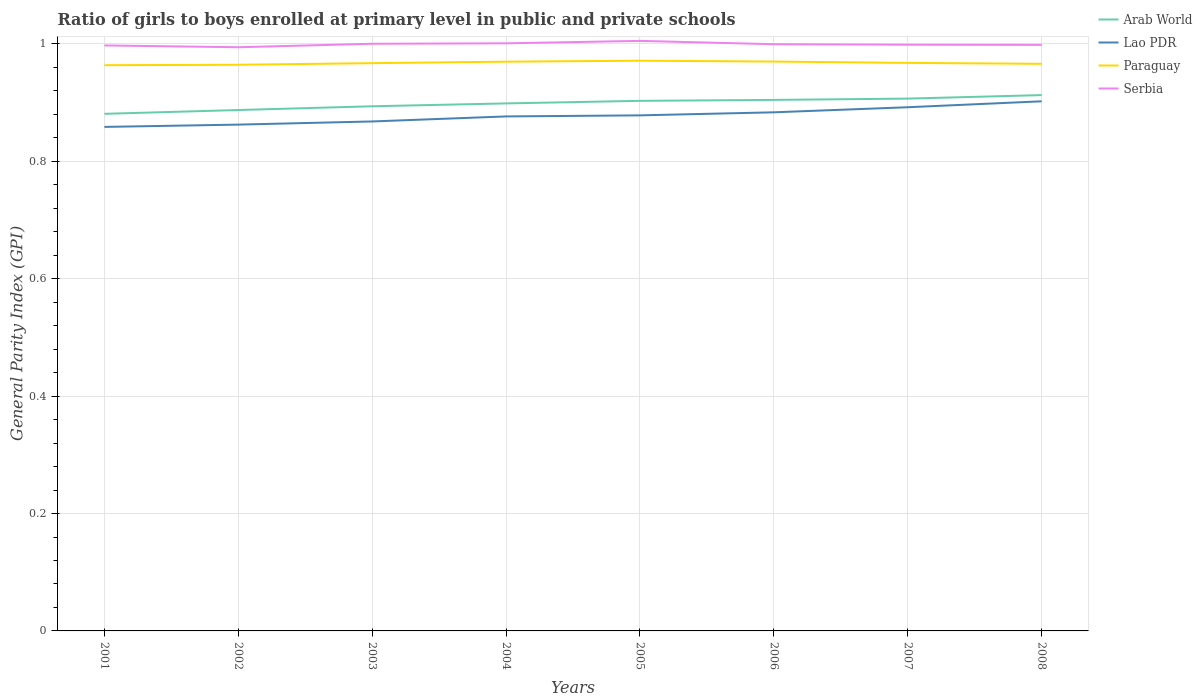How many different coloured lines are there?
Offer a terse response. 4. Does the line corresponding to Arab World intersect with the line corresponding to Serbia?
Give a very brief answer. No. Is the number of lines equal to the number of legend labels?
Offer a terse response. Yes. Across all years, what is the maximum general parity index in Lao PDR?
Ensure brevity in your answer.  0.86. What is the total general parity index in Serbia in the graph?
Make the answer very short. 0. What is the difference between the highest and the second highest general parity index in Paraguay?
Make the answer very short. 0.01. Are the values on the major ticks of Y-axis written in scientific E-notation?
Your response must be concise. No. Does the graph contain any zero values?
Your answer should be compact. No. What is the title of the graph?
Your answer should be compact. Ratio of girls to boys enrolled at primary level in public and private schools. What is the label or title of the Y-axis?
Your answer should be compact. General Parity Index (GPI). What is the General Parity Index (GPI) in Arab World in 2001?
Your answer should be very brief. 0.88. What is the General Parity Index (GPI) of Lao PDR in 2001?
Make the answer very short. 0.86. What is the General Parity Index (GPI) of Paraguay in 2001?
Provide a short and direct response. 0.96. What is the General Parity Index (GPI) of Serbia in 2001?
Provide a short and direct response. 1. What is the General Parity Index (GPI) of Arab World in 2002?
Make the answer very short. 0.89. What is the General Parity Index (GPI) in Lao PDR in 2002?
Your response must be concise. 0.86. What is the General Parity Index (GPI) in Paraguay in 2002?
Keep it short and to the point. 0.96. What is the General Parity Index (GPI) in Serbia in 2002?
Offer a terse response. 0.99. What is the General Parity Index (GPI) of Arab World in 2003?
Your response must be concise. 0.89. What is the General Parity Index (GPI) in Lao PDR in 2003?
Your answer should be compact. 0.87. What is the General Parity Index (GPI) of Paraguay in 2003?
Provide a succinct answer. 0.97. What is the General Parity Index (GPI) of Serbia in 2003?
Your answer should be very brief. 1. What is the General Parity Index (GPI) in Arab World in 2004?
Provide a short and direct response. 0.9. What is the General Parity Index (GPI) in Lao PDR in 2004?
Your answer should be compact. 0.88. What is the General Parity Index (GPI) in Paraguay in 2004?
Keep it short and to the point. 0.97. What is the General Parity Index (GPI) in Serbia in 2004?
Your answer should be compact. 1. What is the General Parity Index (GPI) in Arab World in 2005?
Provide a short and direct response. 0.9. What is the General Parity Index (GPI) in Lao PDR in 2005?
Offer a terse response. 0.88. What is the General Parity Index (GPI) of Paraguay in 2005?
Keep it short and to the point. 0.97. What is the General Parity Index (GPI) of Serbia in 2005?
Keep it short and to the point. 1.01. What is the General Parity Index (GPI) of Arab World in 2006?
Your answer should be very brief. 0.9. What is the General Parity Index (GPI) in Lao PDR in 2006?
Your answer should be very brief. 0.88. What is the General Parity Index (GPI) of Paraguay in 2006?
Offer a very short reply. 0.97. What is the General Parity Index (GPI) of Serbia in 2006?
Your response must be concise. 1. What is the General Parity Index (GPI) of Arab World in 2007?
Give a very brief answer. 0.91. What is the General Parity Index (GPI) in Lao PDR in 2007?
Your response must be concise. 0.89. What is the General Parity Index (GPI) of Paraguay in 2007?
Ensure brevity in your answer.  0.97. What is the General Parity Index (GPI) of Serbia in 2007?
Your response must be concise. 1. What is the General Parity Index (GPI) in Arab World in 2008?
Give a very brief answer. 0.91. What is the General Parity Index (GPI) in Lao PDR in 2008?
Offer a very short reply. 0.9. What is the General Parity Index (GPI) of Paraguay in 2008?
Provide a short and direct response. 0.97. What is the General Parity Index (GPI) in Serbia in 2008?
Ensure brevity in your answer.  1. Across all years, what is the maximum General Parity Index (GPI) of Arab World?
Offer a very short reply. 0.91. Across all years, what is the maximum General Parity Index (GPI) of Lao PDR?
Offer a terse response. 0.9. Across all years, what is the maximum General Parity Index (GPI) in Paraguay?
Offer a very short reply. 0.97. Across all years, what is the maximum General Parity Index (GPI) of Serbia?
Give a very brief answer. 1.01. Across all years, what is the minimum General Parity Index (GPI) in Arab World?
Make the answer very short. 0.88. Across all years, what is the minimum General Parity Index (GPI) of Lao PDR?
Make the answer very short. 0.86. Across all years, what is the minimum General Parity Index (GPI) in Paraguay?
Your answer should be compact. 0.96. Across all years, what is the minimum General Parity Index (GPI) in Serbia?
Offer a very short reply. 0.99. What is the total General Parity Index (GPI) in Arab World in the graph?
Keep it short and to the point. 7.19. What is the total General Parity Index (GPI) in Lao PDR in the graph?
Your answer should be very brief. 7.02. What is the total General Parity Index (GPI) in Paraguay in the graph?
Ensure brevity in your answer.  7.74. What is the total General Parity Index (GPI) of Serbia in the graph?
Provide a short and direct response. 8. What is the difference between the General Parity Index (GPI) in Arab World in 2001 and that in 2002?
Your response must be concise. -0.01. What is the difference between the General Parity Index (GPI) of Lao PDR in 2001 and that in 2002?
Provide a short and direct response. -0. What is the difference between the General Parity Index (GPI) of Paraguay in 2001 and that in 2002?
Your answer should be compact. -0. What is the difference between the General Parity Index (GPI) in Serbia in 2001 and that in 2002?
Your response must be concise. 0. What is the difference between the General Parity Index (GPI) in Arab World in 2001 and that in 2003?
Offer a very short reply. -0.01. What is the difference between the General Parity Index (GPI) in Lao PDR in 2001 and that in 2003?
Make the answer very short. -0.01. What is the difference between the General Parity Index (GPI) in Paraguay in 2001 and that in 2003?
Give a very brief answer. -0. What is the difference between the General Parity Index (GPI) in Serbia in 2001 and that in 2003?
Your response must be concise. -0. What is the difference between the General Parity Index (GPI) in Arab World in 2001 and that in 2004?
Your response must be concise. -0.02. What is the difference between the General Parity Index (GPI) of Lao PDR in 2001 and that in 2004?
Ensure brevity in your answer.  -0.02. What is the difference between the General Parity Index (GPI) in Paraguay in 2001 and that in 2004?
Keep it short and to the point. -0.01. What is the difference between the General Parity Index (GPI) of Serbia in 2001 and that in 2004?
Your answer should be compact. -0. What is the difference between the General Parity Index (GPI) in Arab World in 2001 and that in 2005?
Offer a very short reply. -0.02. What is the difference between the General Parity Index (GPI) in Lao PDR in 2001 and that in 2005?
Make the answer very short. -0.02. What is the difference between the General Parity Index (GPI) in Paraguay in 2001 and that in 2005?
Your answer should be compact. -0.01. What is the difference between the General Parity Index (GPI) of Serbia in 2001 and that in 2005?
Make the answer very short. -0.01. What is the difference between the General Parity Index (GPI) in Arab World in 2001 and that in 2006?
Make the answer very short. -0.02. What is the difference between the General Parity Index (GPI) in Lao PDR in 2001 and that in 2006?
Your answer should be compact. -0.02. What is the difference between the General Parity Index (GPI) in Paraguay in 2001 and that in 2006?
Ensure brevity in your answer.  -0.01. What is the difference between the General Parity Index (GPI) in Serbia in 2001 and that in 2006?
Provide a short and direct response. -0. What is the difference between the General Parity Index (GPI) in Arab World in 2001 and that in 2007?
Offer a terse response. -0.03. What is the difference between the General Parity Index (GPI) of Lao PDR in 2001 and that in 2007?
Provide a short and direct response. -0.03. What is the difference between the General Parity Index (GPI) of Paraguay in 2001 and that in 2007?
Provide a short and direct response. -0. What is the difference between the General Parity Index (GPI) of Serbia in 2001 and that in 2007?
Your response must be concise. -0. What is the difference between the General Parity Index (GPI) in Arab World in 2001 and that in 2008?
Your answer should be compact. -0.03. What is the difference between the General Parity Index (GPI) in Lao PDR in 2001 and that in 2008?
Provide a succinct answer. -0.04. What is the difference between the General Parity Index (GPI) in Paraguay in 2001 and that in 2008?
Your answer should be very brief. -0. What is the difference between the General Parity Index (GPI) of Serbia in 2001 and that in 2008?
Offer a terse response. -0. What is the difference between the General Parity Index (GPI) of Arab World in 2002 and that in 2003?
Keep it short and to the point. -0.01. What is the difference between the General Parity Index (GPI) of Lao PDR in 2002 and that in 2003?
Your answer should be compact. -0.01. What is the difference between the General Parity Index (GPI) of Paraguay in 2002 and that in 2003?
Your answer should be very brief. -0. What is the difference between the General Parity Index (GPI) in Serbia in 2002 and that in 2003?
Give a very brief answer. -0.01. What is the difference between the General Parity Index (GPI) in Arab World in 2002 and that in 2004?
Offer a terse response. -0.01. What is the difference between the General Parity Index (GPI) in Lao PDR in 2002 and that in 2004?
Ensure brevity in your answer.  -0.01. What is the difference between the General Parity Index (GPI) in Paraguay in 2002 and that in 2004?
Make the answer very short. -0.01. What is the difference between the General Parity Index (GPI) in Serbia in 2002 and that in 2004?
Make the answer very short. -0.01. What is the difference between the General Parity Index (GPI) of Arab World in 2002 and that in 2005?
Your answer should be very brief. -0.02. What is the difference between the General Parity Index (GPI) of Lao PDR in 2002 and that in 2005?
Make the answer very short. -0.02. What is the difference between the General Parity Index (GPI) of Paraguay in 2002 and that in 2005?
Provide a succinct answer. -0.01. What is the difference between the General Parity Index (GPI) in Serbia in 2002 and that in 2005?
Keep it short and to the point. -0.01. What is the difference between the General Parity Index (GPI) of Arab World in 2002 and that in 2006?
Make the answer very short. -0.02. What is the difference between the General Parity Index (GPI) of Lao PDR in 2002 and that in 2006?
Provide a short and direct response. -0.02. What is the difference between the General Parity Index (GPI) of Paraguay in 2002 and that in 2006?
Make the answer very short. -0.01. What is the difference between the General Parity Index (GPI) of Serbia in 2002 and that in 2006?
Your answer should be very brief. -0.01. What is the difference between the General Parity Index (GPI) in Arab World in 2002 and that in 2007?
Give a very brief answer. -0.02. What is the difference between the General Parity Index (GPI) in Lao PDR in 2002 and that in 2007?
Your response must be concise. -0.03. What is the difference between the General Parity Index (GPI) in Paraguay in 2002 and that in 2007?
Offer a very short reply. -0. What is the difference between the General Parity Index (GPI) in Serbia in 2002 and that in 2007?
Offer a very short reply. -0. What is the difference between the General Parity Index (GPI) in Arab World in 2002 and that in 2008?
Provide a short and direct response. -0.03. What is the difference between the General Parity Index (GPI) of Lao PDR in 2002 and that in 2008?
Your answer should be compact. -0.04. What is the difference between the General Parity Index (GPI) of Paraguay in 2002 and that in 2008?
Keep it short and to the point. -0. What is the difference between the General Parity Index (GPI) of Serbia in 2002 and that in 2008?
Make the answer very short. -0. What is the difference between the General Parity Index (GPI) of Arab World in 2003 and that in 2004?
Give a very brief answer. -0. What is the difference between the General Parity Index (GPI) of Lao PDR in 2003 and that in 2004?
Provide a succinct answer. -0.01. What is the difference between the General Parity Index (GPI) of Paraguay in 2003 and that in 2004?
Make the answer very short. -0. What is the difference between the General Parity Index (GPI) in Serbia in 2003 and that in 2004?
Ensure brevity in your answer.  -0. What is the difference between the General Parity Index (GPI) in Arab World in 2003 and that in 2005?
Ensure brevity in your answer.  -0.01. What is the difference between the General Parity Index (GPI) of Lao PDR in 2003 and that in 2005?
Your answer should be very brief. -0.01. What is the difference between the General Parity Index (GPI) in Paraguay in 2003 and that in 2005?
Provide a short and direct response. -0. What is the difference between the General Parity Index (GPI) of Serbia in 2003 and that in 2005?
Make the answer very short. -0. What is the difference between the General Parity Index (GPI) in Arab World in 2003 and that in 2006?
Offer a very short reply. -0.01. What is the difference between the General Parity Index (GPI) of Lao PDR in 2003 and that in 2006?
Make the answer very short. -0.02. What is the difference between the General Parity Index (GPI) of Paraguay in 2003 and that in 2006?
Make the answer very short. -0. What is the difference between the General Parity Index (GPI) in Serbia in 2003 and that in 2006?
Keep it short and to the point. 0. What is the difference between the General Parity Index (GPI) in Arab World in 2003 and that in 2007?
Your response must be concise. -0.01. What is the difference between the General Parity Index (GPI) in Lao PDR in 2003 and that in 2007?
Give a very brief answer. -0.02. What is the difference between the General Parity Index (GPI) in Paraguay in 2003 and that in 2007?
Your answer should be compact. -0. What is the difference between the General Parity Index (GPI) of Serbia in 2003 and that in 2007?
Give a very brief answer. 0. What is the difference between the General Parity Index (GPI) of Arab World in 2003 and that in 2008?
Provide a succinct answer. -0.02. What is the difference between the General Parity Index (GPI) of Lao PDR in 2003 and that in 2008?
Your answer should be compact. -0.03. What is the difference between the General Parity Index (GPI) of Paraguay in 2003 and that in 2008?
Ensure brevity in your answer.  0. What is the difference between the General Parity Index (GPI) in Serbia in 2003 and that in 2008?
Your answer should be compact. 0. What is the difference between the General Parity Index (GPI) of Arab World in 2004 and that in 2005?
Give a very brief answer. -0. What is the difference between the General Parity Index (GPI) in Lao PDR in 2004 and that in 2005?
Offer a terse response. -0. What is the difference between the General Parity Index (GPI) of Paraguay in 2004 and that in 2005?
Give a very brief answer. -0. What is the difference between the General Parity Index (GPI) of Serbia in 2004 and that in 2005?
Ensure brevity in your answer.  -0. What is the difference between the General Parity Index (GPI) in Arab World in 2004 and that in 2006?
Offer a terse response. -0.01. What is the difference between the General Parity Index (GPI) in Lao PDR in 2004 and that in 2006?
Your response must be concise. -0.01. What is the difference between the General Parity Index (GPI) of Paraguay in 2004 and that in 2006?
Give a very brief answer. -0. What is the difference between the General Parity Index (GPI) in Serbia in 2004 and that in 2006?
Keep it short and to the point. 0. What is the difference between the General Parity Index (GPI) of Arab World in 2004 and that in 2007?
Make the answer very short. -0.01. What is the difference between the General Parity Index (GPI) of Lao PDR in 2004 and that in 2007?
Keep it short and to the point. -0.02. What is the difference between the General Parity Index (GPI) of Paraguay in 2004 and that in 2007?
Ensure brevity in your answer.  0. What is the difference between the General Parity Index (GPI) of Serbia in 2004 and that in 2007?
Keep it short and to the point. 0. What is the difference between the General Parity Index (GPI) of Arab World in 2004 and that in 2008?
Your response must be concise. -0.01. What is the difference between the General Parity Index (GPI) of Lao PDR in 2004 and that in 2008?
Your answer should be compact. -0.03. What is the difference between the General Parity Index (GPI) of Paraguay in 2004 and that in 2008?
Ensure brevity in your answer.  0. What is the difference between the General Parity Index (GPI) of Serbia in 2004 and that in 2008?
Make the answer very short. 0. What is the difference between the General Parity Index (GPI) in Arab World in 2005 and that in 2006?
Give a very brief answer. -0. What is the difference between the General Parity Index (GPI) of Lao PDR in 2005 and that in 2006?
Ensure brevity in your answer.  -0.01. What is the difference between the General Parity Index (GPI) in Paraguay in 2005 and that in 2006?
Ensure brevity in your answer.  0. What is the difference between the General Parity Index (GPI) in Serbia in 2005 and that in 2006?
Your answer should be compact. 0.01. What is the difference between the General Parity Index (GPI) in Arab World in 2005 and that in 2007?
Your answer should be compact. -0. What is the difference between the General Parity Index (GPI) in Lao PDR in 2005 and that in 2007?
Provide a succinct answer. -0.01. What is the difference between the General Parity Index (GPI) in Paraguay in 2005 and that in 2007?
Your answer should be very brief. 0. What is the difference between the General Parity Index (GPI) in Serbia in 2005 and that in 2007?
Your answer should be compact. 0.01. What is the difference between the General Parity Index (GPI) of Arab World in 2005 and that in 2008?
Keep it short and to the point. -0.01. What is the difference between the General Parity Index (GPI) of Lao PDR in 2005 and that in 2008?
Offer a terse response. -0.02. What is the difference between the General Parity Index (GPI) of Paraguay in 2005 and that in 2008?
Your answer should be compact. 0.01. What is the difference between the General Parity Index (GPI) of Serbia in 2005 and that in 2008?
Your answer should be very brief. 0.01. What is the difference between the General Parity Index (GPI) in Arab World in 2006 and that in 2007?
Give a very brief answer. -0. What is the difference between the General Parity Index (GPI) of Lao PDR in 2006 and that in 2007?
Your answer should be very brief. -0.01. What is the difference between the General Parity Index (GPI) in Paraguay in 2006 and that in 2007?
Your response must be concise. 0. What is the difference between the General Parity Index (GPI) in Serbia in 2006 and that in 2007?
Your response must be concise. 0. What is the difference between the General Parity Index (GPI) in Arab World in 2006 and that in 2008?
Give a very brief answer. -0.01. What is the difference between the General Parity Index (GPI) of Lao PDR in 2006 and that in 2008?
Your response must be concise. -0.02. What is the difference between the General Parity Index (GPI) of Paraguay in 2006 and that in 2008?
Your answer should be compact. 0. What is the difference between the General Parity Index (GPI) of Serbia in 2006 and that in 2008?
Keep it short and to the point. 0. What is the difference between the General Parity Index (GPI) in Arab World in 2007 and that in 2008?
Provide a short and direct response. -0.01. What is the difference between the General Parity Index (GPI) in Lao PDR in 2007 and that in 2008?
Make the answer very short. -0.01. What is the difference between the General Parity Index (GPI) of Paraguay in 2007 and that in 2008?
Provide a succinct answer. 0. What is the difference between the General Parity Index (GPI) in Serbia in 2007 and that in 2008?
Give a very brief answer. 0. What is the difference between the General Parity Index (GPI) of Arab World in 2001 and the General Parity Index (GPI) of Lao PDR in 2002?
Your answer should be very brief. 0.02. What is the difference between the General Parity Index (GPI) of Arab World in 2001 and the General Parity Index (GPI) of Paraguay in 2002?
Give a very brief answer. -0.08. What is the difference between the General Parity Index (GPI) of Arab World in 2001 and the General Parity Index (GPI) of Serbia in 2002?
Give a very brief answer. -0.11. What is the difference between the General Parity Index (GPI) in Lao PDR in 2001 and the General Parity Index (GPI) in Paraguay in 2002?
Your answer should be very brief. -0.11. What is the difference between the General Parity Index (GPI) in Lao PDR in 2001 and the General Parity Index (GPI) in Serbia in 2002?
Give a very brief answer. -0.14. What is the difference between the General Parity Index (GPI) in Paraguay in 2001 and the General Parity Index (GPI) in Serbia in 2002?
Offer a terse response. -0.03. What is the difference between the General Parity Index (GPI) of Arab World in 2001 and the General Parity Index (GPI) of Lao PDR in 2003?
Give a very brief answer. 0.01. What is the difference between the General Parity Index (GPI) in Arab World in 2001 and the General Parity Index (GPI) in Paraguay in 2003?
Keep it short and to the point. -0.09. What is the difference between the General Parity Index (GPI) in Arab World in 2001 and the General Parity Index (GPI) in Serbia in 2003?
Give a very brief answer. -0.12. What is the difference between the General Parity Index (GPI) of Lao PDR in 2001 and the General Parity Index (GPI) of Paraguay in 2003?
Your answer should be compact. -0.11. What is the difference between the General Parity Index (GPI) of Lao PDR in 2001 and the General Parity Index (GPI) of Serbia in 2003?
Keep it short and to the point. -0.14. What is the difference between the General Parity Index (GPI) of Paraguay in 2001 and the General Parity Index (GPI) of Serbia in 2003?
Your answer should be very brief. -0.04. What is the difference between the General Parity Index (GPI) of Arab World in 2001 and the General Parity Index (GPI) of Lao PDR in 2004?
Provide a succinct answer. 0. What is the difference between the General Parity Index (GPI) in Arab World in 2001 and the General Parity Index (GPI) in Paraguay in 2004?
Provide a succinct answer. -0.09. What is the difference between the General Parity Index (GPI) of Arab World in 2001 and the General Parity Index (GPI) of Serbia in 2004?
Your response must be concise. -0.12. What is the difference between the General Parity Index (GPI) of Lao PDR in 2001 and the General Parity Index (GPI) of Paraguay in 2004?
Provide a succinct answer. -0.11. What is the difference between the General Parity Index (GPI) of Lao PDR in 2001 and the General Parity Index (GPI) of Serbia in 2004?
Ensure brevity in your answer.  -0.14. What is the difference between the General Parity Index (GPI) in Paraguay in 2001 and the General Parity Index (GPI) in Serbia in 2004?
Offer a terse response. -0.04. What is the difference between the General Parity Index (GPI) in Arab World in 2001 and the General Parity Index (GPI) in Lao PDR in 2005?
Ensure brevity in your answer.  0. What is the difference between the General Parity Index (GPI) in Arab World in 2001 and the General Parity Index (GPI) in Paraguay in 2005?
Your answer should be very brief. -0.09. What is the difference between the General Parity Index (GPI) of Arab World in 2001 and the General Parity Index (GPI) of Serbia in 2005?
Offer a terse response. -0.12. What is the difference between the General Parity Index (GPI) of Lao PDR in 2001 and the General Parity Index (GPI) of Paraguay in 2005?
Make the answer very short. -0.11. What is the difference between the General Parity Index (GPI) in Lao PDR in 2001 and the General Parity Index (GPI) in Serbia in 2005?
Provide a short and direct response. -0.15. What is the difference between the General Parity Index (GPI) of Paraguay in 2001 and the General Parity Index (GPI) of Serbia in 2005?
Your answer should be compact. -0.04. What is the difference between the General Parity Index (GPI) of Arab World in 2001 and the General Parity Index (GPI) of Lao PDR in 2006?
Provide a succinct answer. -0. What is the difference between the General Parity Index (GPI) in Arab World in 2001 and the General Parity Index (GPI) in Paraguay in 2006?
Provide a succinct answer. -0.09. What is the difference between the General Parity Index (GPI) of Arab World in 2001 and the General Parity Index (GPI) of Serbia in 2006?
Provide a succinct answer. -0.12. What is the difference between the General Parity Index (GPI) in Lao PDR in 2001 and the General Parity Index (GPI) in Paraguay in 2006?
Your response must be concise. -0.11. What is the difference between the General Parity Index (GPI) in Lao PDR in 2001 and the General Parity Index (GPI) in Serbia in 2006?
Give a very brief answer. -0.14. What is the difference between the General Parity Index (GPI) of Paraguay in 2001 and the General Parity Index (GPI) of Serbia in 2006?
Keep it short and to the point. -0.04. What is the difference between the General Parity Index (GPI) of Arab World in 2001 and the General Parity Index (GPI) of Lao PDR in 2007?
Give a very brief answer. -0.01. What is the difference between the General Parity Index (GPI) in Arab World in 2001 and the General Parity Index (GPI) in Paraguay in 2007?
Offer a terse response. -0.09. What is the difference between the General Parity Index (GPI) in Arab World in 2001 and the General Parity Index (GPI) in Serbia in 2007?
Offer a very short reply. -0.12. What is the difference between the General Parity Index (GPI) in Lao PDR in 2001 and the General Parity Index (GPI) in Paraguay in 2007?
Offer a very short reply. -0.11. What is the difference between the General Parity Index (GPI) of Lao PDR in 2001 and the General Parity Index (GPI) of Serbia in 2007?
Provide a succinct answer. -0.14. What is the difference between the General Parity Index (GPI) in Paraguay in 2001 and the General Parity Index (GPI) in Serbia in 2007?
Give a very brief answer. -0.03. What is the difference between the General Parity Index (GPI) in Arab World in 2001 and the General Parity Index (GPI) in Lao PDR in 2008?
Provide a short and direct response. -0.02. What is the difference between the General Parity Index (GPI) of Arab World in 2001 and the General Parity Index (GPI) of Paraguay in 2008?
Provide a succinct answer. -0.09. What is the difference between the General Parity Index (GPI) in Arab World in 2001 and the General Parity Index (GPI) in Serbia in 2008?
Offer a terse response. -0.12. What is the difference between the General Parity Index (GPI) in Lao PDR in 2001 and the General Parity Index (GPI) in Paraguay in 2008?
Make the answer very short. -0.11. What is the difference between the General Parity Index (GPI) in Lao PDR in 2001 and the General Parity Index (GPI) in Serbia in 2008?
Ensure brevity in your answer.  -0.14. What is the difference between the General Parity Index (GPI) in Paraguay in 2001 and the General Parity Index (GPI) in Serbia in 2008?
Offer a terse response. -0.03. What is the difference between the General Parity Index (GPI) of Arab World in 2002 and the General Parity Index (GPI) of Lao PDR in 2003?
Make the answer very short. 0.02. What is the difference between the General Parity Index (GPI) in Arab World in 2002 and the General Parity Index (GPI) in Paraguay in 2003?
Ensure brevity in your answer.  -0.08. What is the difference between the General Parity Index (GPI) of Arab World in 2002 and the General Parity Index (GPI) of Serbia in 2003?
Your answer should be very brief. -0.11. What is the difference between the General Parity Index (GPI) of Lao PDR in 2002 and the General Parity Index (GPI) of Paraguay in 2003?
Give a very brief answer. -0.1. What is the difference between the General Parity Index (GPI) of Lao PDR in 2002 and the General Parity Index (GPI) of Serbia in 2003?
Make the answer very short. -0.14. What is the difference between the General Parity Index (GPI) of Paraguay in 2002 and the General Parity Index (GPI) of Serbia in 2003?
Your answer should be compact. -0.04. What is the difference between the General Parity Index (GPI) in Arab World in 2002 and the General Parity Index (GPI) in Lao PDR in 2004?
Offer a very short reply. 0.01. What is the difference between the General Parity Index (GPI) in Arab World in 2002 and the General Parity Index (GPI) in Paraguay in 2004?
Provide a succinct answer. -0.08. What is the difference between the General Parity Index (GPI) in Arab World in 2002 and the General Parity Index (GPI) in Serbia in 2004?
Provide a short and direct response. -0.11. What is the difference between the General Parity Index (GPI) of Lao PDR in 2002 and the General Parity Index (GPI) of Paraguay in 2004?
Provide a short and direct response. -0.11. What is the difference between the General Parity Index (GPI) of Lao PDR in 2002 and the General Parity Index (GPI) of Serbia in 2004?
Keep it short and to the point. -0.14. What is the difference between the General Parity Index (GPI) in Paraguay in 2002 and the General Parity Index (GPI) in Serbia in 2004?
Keep it short and to the point. -0.04. What is the difference between the General Parity Index (GPI) in Arab World in 2002 and the General Parity Index (GPI) in Lao PDR in 2005?
Give a very brief answer. 0.01. What is the difference between the General Parity Index (GPI) of Arab World in 2002 and the General Parity Index (GPI) of Paraguay in 2005?
Provide a succinct answer. -0.08. What is the difference between the General Parity Index (GPI) in Arab World in 2002 and the General Parity Index (GPI) in Serbia in 2005?
Provide a succinct answer. -0.12. What is the difference between the General Parity Index (GPI) of Lao PDR in 2002 and the General Parity Index (GPI) of Paraguay in 2005?
Provide a succinct answer. -0.11. What is the difference between the General Parity Index (GPI) of Lao PDR in 2002 and the General Parity Index (GPI) of Serbia in 2005?
Ensure brevity in your answer.  -0.14. What is the difference between the General Parity Index (GPI) of Paraguay in 2002 and the General Parity Index (GPI) of Serbia in 2005?
Your answer should be compact. -0.04. What is the difference between the General Parity Index (GPI) of Arab World in 2002 and the General Parity Index (GPI) of Lao PDR in 2006?
Ensure brevity in your answer.  0. What is the difference between the General Parity Index (GPI) of Arab World in 2002 and the General Parity Index (GPI) of Paraguay in 2006?
Keep it short and to the point. -0.08. What is the difference between the General Parity Index (GPI) in Arab World in 2002 and the General Parity Index (GPI) in Serbia in 2006?
Ensure brevity in your answer.  -0.11. What is the difference between the General Parity Index (GPI) in Lao PDR in 2002 and the General Parity Index (GPI) in Paraguay in 2006?
Your answer should be very brief. -0.11. What is the difference between the General Parity Index (GPI) of Lao PDR in 2002 and the General Parity Index (GPI) of Serbia in 2006?
Offer a terse response. -0.14. What is the difference between the General Parity Index (GPI) in Paraguay in 2002 and the General Parity Index (GPI) in Serbia in 2006?
Offer a very short reply. -0.04. What is the difference between the General Parity Index (GPI) in Arab World in 2002 and the General Parity Index (GPI) in Lao PDR in 2007?
Your answer should be compact. -0. What is the difference between the General Parity Index (GPI) of Arab World in 2002 and the General Parity Index (GPI) of Paraguay in 2007?
Provide a succinct answer. -0.08. What is the difference between the General Parity Index (GPI) of Arab World in 2002 and the General Parity Index (GPI) of Serbia in 2007?
Offer a very short reply. -0.11. What is the difference between the General Parity Index (GPI) of Lao PDR in 2002 and the General Parity Index (GPI) of Paraguay in 2007?
Offer a very short reply. -0.11. What is the difference between the General Parity Index (GPI) in Lao PDR in 2002 and the General Parity Index (GPI) in Serbia in 2007?
Make the answer very short. -0.14. What is the difference between the General Parity Index (GPI) of Paraguay in 2002 and the General Parity Index (GPI) of Serbia in 2007?
Provide a short and direct response. -0.03. What is the difference between the General Parity Index (GPI) of Arab World in 2002 and the General Parity Index (GPI) of Lao PDR in 2008?
Your answer should be compact. -0.01. What is the difference between the General Parity Index (GPI) in Arab World in 2002 and the General Parity Index (GPI) in Paraguay in 2008?
Provide a succinct answer. -0.08. What is the difference between the General Parity Index (GPI) of Arab World in 2002 and the General Parity Index (GPI) of Serbia in 2008?
Offer a very short reply. -0.11. What is the difference between the General Parity Index (GPI) in Lao PDR in 2002 and the General Parity Index (GPI) in Paraguay in 2008?
Your response must be concise. -0.1. What is the difference between the General Parity Index (GPI) of Lao PDR in 2002 and the General Parity Index (GPI) of Serbia in 2008?
Offer a terse response. -0.14. What is the difference between the General Parity Index (GPI) in Paraguay in 2002 and the General Parity Index (GPI) in Serbia in 2008?
Give a very brief answer. -0.03. What is the difference between the General Parity Index (GPI) of Arab World in 2003 and the General Parity Index (GPI) of Lao PDR in 2004?
Your answer should be compact. 0.02. What is the difference between the General Parity Index (GPI) of Arab World in 2003 and the General Parity Index (GPI) of Paraguay in 2004?
Keep it short and to the point. -0.08. What is the difference between the General Parity Index (GPI) in Arab World in 2003 and the General Parity Index (GPI) in Serbia in 2004?
Provide a short and direct response. -0.11. What is the difference between the General Parity Index (GPI) in Lao PDR in 2003 and the General Parity Index (GPI) in Paraguay in 2004?
Your response must be concise. -0.1. What is the difference between the General Parity Index (GPI) of Lao PDR in 2003 and the General Parity Index (GPI) of Serbia in 2004?
Your response must be concise. -0.13. What is the difference between the General Parity Index (GPI) of Paraguay in 2003 and the General Parity Index (GPI) of Serbia in 2004?
Keep it short and to the point. -0.03. What is the difference between the General Parity Index (GPI) in Arab World in 2003 and the General Parity Index (GPI) in Lao PDR in 2005?
Keep it short and to the point. 0.02. What is the difference between the General Parity Index (GPI) of Arab World in 2003 and the General Parity Index (GPI) of Paraguay in 2005?
Provide a short and direct response. -0.08. What is the difference between the General Parity Index (GPI) of Arab World in 2003 and the General Parity Index (GPI) of Serbia in 2005?
Your response must be concise. -0.11. What is the difference between the General Parity Index (GPI) in Lao PDR in 2003 and the General Parity Index (GPI) in Paraguay in 2005?
Your answer should be compact. -0.1. What is the difference between the General Parity Index (GPI) of Lao PDR in 2003 and the General Parity Index (GPI) of Serbia in 2005?
Give a very brief answer. -0.14. What is the difference between the General Parity Index (GPI) of Paraguay in 2003 and the General Parity Index (GPI) of Serbia in 2005?
Provide a short and direct response. -0.04. What is the difference between the General Parity Index (GPI) in Arab World in 2003 and the General Parity Index (GPI) in Lao PDR in 2006?
Your answer should be very brief. 0.01. What is the difference between the General Parity Index (GPI) in Arab World in 2003 and the General Parity Index (GPI) in Paraguay in 2006?
Your answer should be very brief. -0.08. What is the difference between the General Parity Index (GPI) of Arab World in 2003 and the General Parity Index (GPI) of Serbia in 2006?
Give a very brief answer. -0.11. What is the difference between the General Parity Index (GPI) in Lao PDR in 2003 and the General Parity Index (GPI) in Paraguay in 2006?
Ensure brevity in your answer.  -0.1. What is the difference between the General Parity Index (GPI) of Lao PDR in 2003 and the General Parity Index (GPI) of Serbia in 2006?
Keep it short and to the point. -0.13. What is the difference between the General Parity Index (GPI) of Paraguay in 2003 and the General Parity Index (GPI) of Serbia in 2006?
Provide a short and direct response. -0.03. What is the difference between the General Parity Index (GPI) in Arab World in 2003 and the General Parity Index (GPI) in Lao PDR in 2007?
Offer a very short reply. 0. What is the difference between the General Parity Index (GPI) in Arab World in 2003 and the General Parity Index (GPI) in Paraguay in 2007?
Offer a very short reply. -0.07. What is the difference between the General Parity Index (GPI) of Arab World in 2003 and the General Parity Index (GPI) of Serbia in 2007?
Make the answer very short. -0.1. What is the difference between the General Parity Index (GPI) of Lao PDR in 2003 and the General Parity Index (GPI) of Paraguay in 2007?
Provide a succinct answer. -0.1. What is the difference between the General Parity Index (GPI) in Lao PDR in 2003 and the General Parity Index (GPI) in Serbia in 2007?
Your answer should be very brief. -0.13. What is the difference between the General Parity Index (GPI) in Paraguay in 2003 and the General Parity Index (GPI) in Serbia in 2007?
Your answer should be compact. -0.03. What is the difference between the General Parity Index (GPI) in Arab World in 2003 and the General Parity Index (GPI) in Lao PDR in 2008?
Give a very brief answer. -0.01. What is the difference between the General Parity Index (GPI) in Arab World in 2003 and the General Parity Index (GPI) in Paraguay in 2008?
Provide a short and direct response. -0.07. What is the difference between the General Parity Index (GPI) of Arab World in 2003 and the General Parity Index (GPI) of Serbia in 2008?
Make the answer very short. -0.1. What is the difference between the General Parity Index (GPI) in Lao PDR in 2003 and the General Parity Index (GPI) in Paraguay in 2008?
Give a very brief answer. -0.1. What is the difference between the General Parity Index (GPI) in Lao PDR in 2003 and the General Parity Index (GPI) in Serbia in 2008?
Offer a very short reply. -0.13. What is the difference between the General Parity Index (GPI) of Paraguay in 2003 and the General Parity Index (GPI) of Serbia in 2008?
Give a very brief answer. -0.03. What is the difference between the General Parity Index (GPI) of Arab World in 2004 and the General Parity Index (GPI) of Lao PDR in 2005?
Give a very brief answer. 0.02. What is the difference between the General Parity Index (GPI) in Arab World in 2004 and the General Parity Index (GPI) in Paraguay in 2005?
Keep it short and to the point. -0.07. What is the difference between the General Parity Index (GPI) of Arab World in 2004 and the General Parity Index (GPI) of Serbia in 2005?
Make the answer very short. -0.11. What is the difference between the General Parity Index (GPI) of Lao PDR in 2004 and the General Parity Index (GPI) of Paraguay in 2005?
Provide a short and direct response. -0.09. What is the difference between the General Parity Index (GPI) in Lao PDR in 2004 and the General Parity Index (GPI) in Serbia in 2005?
Keep it short and to the point. -0.13. What is the difference between the General Parity Index (GPI) in Paraguay in 2004 and the General Parity Index (GPI) in Serbia in 2005?
Offer a very short reply. -0.04. What is the difference between the General Parity Index (GPI) in Arab World in 2004 and the General Parity Index (GPI) in Lao PDR in 2006?
Ensure brevity in your answer.  0.02. What is the difference between the General Parity Index (GPI) in Arab World in 2004 and the General Parity Index (GPI) in Paraguay in 2006?
Offer a very short reply. -0.07. What is the difference between the General Parity Index (GPI) in Arab World in 2004 and the General Parity Index (GPI) in Serbia in 2006?
Provide a succinct answer. -0.1. What is the difference between the General Parity Index (GPI) of Lao PDR in 2004 and the General Parity Index (GPI) of Paraguay in 2006?
Your response must be concise. -0.09. What is the difference between the General Parity Index (GPI) in Lao PDR in 2004 and the General Parity Index (GPI) in Serbia in 2006?
Provide a succinct answer. -0.12. What is the difference between the General Parity Index (GPI) of Paraguay in 2004 and the General Parity Index (GPI) of Serbia in 2006?
Provide a succinct answer. -0.03. What is the difference between the General Parity Index (GPI) in Arab World in 2004 and the General Parity Index (GPI) in Lao PDR in 2007?
Provide a succinct answer. 0.01. What is the difference between the General Parity Index (GPI) of Arab World in 2004 and the General Parity Index (GPI) of Paraguay in 2007?
Ensure brevity in your answer.  -0.07. What is the difference between the General Parity Index (GPI) in Lao PDR in 2004 and the General Parity Index (GPI) in Paraguay in 2007?
Ensure brevity in your answer.  -0.09. What is the difference between the General Parity Index (GPI) of Lao PDR in 2004 and the General Parity Index (GPI) of Serbia in 2007?
Provide a succinct answer. -0.12. What is the difference between the General Parity Index (GPI) of Paraguay in 2004 and the General Parity Index (GPI) of Serbia in 2007?
Make the answer very short. -0.03. What is the difference between the General Parity Index (GPI) of Arab World in 2004 and the General Parity Index (GPI) of Lao PDR in 2008?
Provide a succinct answer. -0. What is the difference between the General Parity Index (GPI) of Arab World in 2004 and the General Parity Index (GPI) of Paraguay in 2008?
Make the answer very short. -0.07. What is the difference between the General Parity Index (GPI) of Arab World in 2004 and the General Parity Index (GPI) of Serbia in 2008?
Make the answer very short. -0.1. What is the difference between the General Parity Index (GPI) of Lao PDR in 2004 and the General Parity Index (GPI) of Paraguay in 2008?
Give a very brief answer. -0.09. What is the difference between the General Parity Index (GPI) in Lao PDR in 2004 and the General Parity Index (GPI) in Serbia in 2008?
Provide a succinct answer. -0.12. What is the difference between the General Parity Index (GPI) of Paraguay in 2004 and the General Parity Index (GPI) of Serbia in 2008?
Offer a very short reply. -0.03. What is the difference between the General Parity Index (GPI) of Arab World in 2005 and the General Parity Index (GPI) of Lao PDR in 2006?
Keep it short and to the point. 0.02. What is the difference between the General Parity Index (GPI) in Arab World in 2005 and the General Parity Index (GPI) in Paraguay in 2006?
Keep it short and to the point. -0.07. What is the difference between the General Parity Index (GPI) of Arab World in 2005 and the General Parity Index (GPI) of Serbia in 2006?
Keep it short and to the point. -0.1. What is the difference between the General Parity Index (GPI) in Lao PDR in 2005 and the General Parity Index (GPI) in Paraguay in 2006?
Give a very brief answer. -0.09. What is the difference between the General Parity Index (GPI) of Lao PDR in 2005 and the General Parity Index (GPI) of Serbia in 2006?
Your answer should be very brief. -0.12. What is the difference between the General Parity Index (GPI) of Paraguay in 2005 and the General Parity Index (GPI) of Serbia in 2006?
Make the answer very short. -0.03. What is the difference between the General Parity Index (GPI) of Arab World in 2005 and the General Parity Index (GPI) of Lao PDR in 2007?
Provide a succinct answer. 0.01. What is the difference between the General Parity Index (GPI) in Arab World in 2005 and the General Parity Index (GPI) in Paraguay in 2007?
Your answer should be compact. -0.06. What is the difference between the General Parity Index (GPI) in Arab World in 2005 and the General Parity Index (GPI) in Serbia in 2007?
Offer a very short reply. -0.1. What is the difference between the General Parity Index (GPI) in Lao PDR in 2005 and the General Parity Index (GPI) in Paraguay in 2007?
Provide a short and direct response. -0.09. What is the difference between the General Parity Index (GPI) in Lao PDR in 2005 and the General Parity Index (GPI) in Serbia in 2007?
Offer a terse response. -0.12. What is the difference between the General Parity Index (GPI) of Paraguay in 2005 and the General Parity Index (GPI) of Serbia in 2007?
Your response must be concise. -0.03. What is the difference between the General Parity Index (GPI) in Arab World in 2005 and the General Parity Index (GPI) in Lao PDR in 2008?
Your response must be concise. 0. What is the difference between the General Parity Index (GPI) in Arab World in 2005 and the General Parity Index (GPI) in Paraguay in 2008?
Make the answer very short. -0.06. What is the difference between the General Parity Index (GPI) of Arab World in 2005 and the General Parity Index (GPI) of Serbia in 2008?
Keep it short and to the point. -0.1. What is the difference between the General Parity Index (GPI) of Lao PDR in 2005 and the General Parity Index (GPI) of Paraguay in 2008?
Provide a short and direct response. -0.09. What is the difference between the General Parity Index (GPI) of Lao PDR in 2005 and the General Parity Index (GPI) of Serbia in 2008?
Keep it short and to the point. -0.12. What is the difference between the General Parity Index (GPI) of Paraguay in 2005 and the General Parity Index (GPI) of Serbia in 2008?
Ensure brevity in your answer.  -0.03. What is the difference between the General Parity Index (GPI) in Arab World in 2006 and the General Parity Index (GPI) in Lao PDR in 2007?
Your answer should be very brief. 0.01. What is the difference between the General Parity Index (GPI) of Arab World in 2006 and the General Parity Index (GPI) of Paraguay in 2007?
Ensure brevity in your answer.  -0.06. What is the difference between the General Parity Index (GPI) in Arab World in 2006 and the General Parity Index (GPI) in Serbia in 2007?
Make the answer very short. -0.09. What is the difference between the General Parity Index (GPI) in Lao PDR in 2006 and the General Parity Index (GPI) in Paraguay in 2007?
Your response must be concise. -0.08. What is the difference between the General Parity Index (GPI) in Lao PDR in 2006 and the General Parity Index (GPI) in Serbia in 2007?
Your answer should be compact. -0.12. What is the difference between the General Parity Index (GPI) in Paraguay in 2006 and the General Parity Index (GPI) in Serbia in 2007?
Make the answer very short. -0.03. What is the difference between the General Parity Index (GPI) in Arab World in 2006 and the General Parity Index (GPI) in Lao PDR in 2008?
Offer a terse response. 0. What is the difference between the General Parity Index (GPI) of Arab World in 2006 and the General Parity Index (GPI) of Paraguay in 2008?
Provide a short and direct response. -0.06. What is the difference between the General Parity Index (GPI) in Arab World in 2006 and the General Parity Index (GPI) in Serbia in 2008?
Ensure brevity in your answer.  -0.09. What is the difference between the General Parity Index (GPI) of Lao PDR in 2006 and the General Parity Index (GPI) of Paraguay in 2008?
Your answer should be compact. -0.08. What is the difference between the General Parity Index (GPI) of Lao PDR in 2006 and the General Parity Index (GPI) of Serbia in 2008?
Provide a succinct answer. -0.11. What is the difference between the General Parity Index (GPI) of Paraguay in 2006 and the General Parity Index (GPI) of Serbia in 2008?
Your answer should be compact. -0.03. What is the difference between the General Parity Index (GPI) in Arab World in 2007 and the General Parity Index (GPI) in Lao PDR in 2008?
Make the answer very short. 0. What is the difference between the General Parity Index (GPI) in Arab World in 2007 and the General Parity Index (GPI) in Paraguay in 2008?
Make the answer very short. -0.06. What is the difference between the General Parity Index (GPI) in Arab World in 2007 and the General Parity Index (GPI) in Serbia in 2008?
Give a very brief answer. -0.09. What is the difference between the General Parity Index (GPI) in Lao PDR in 2007 and the General Parity Index (GPI) in Paraguay in 2008?
Your answer should be compact. -0.07. What is the difference between the General Parity Index (GPI) in Lao PDR in 2007 and the General Parity Index (GPI) in Serbia in 2008?
Provide a succinct answer. -0.11. What is the difference between the General Parity Index (GPI) of Paraguay in 2007 and the General Parity Index (GPI) of Serbia in 2008?
Keep it short and to the point. -0.03. What is the average General Parity Index (GPI) of Arab World per year?
Provide a succinct answer. 0.9. What is the average General Parity Index (GPI) of Lao PDR per year?
Keep it short and to the point. 0.88. What is the average General Parity Index (GPI) of Paraguay per year?
Provide a succinct answer. 0.97. In the year 2001, what is the difference between the General Parity Index (GPI) in Arab World and General Parity Index (GPI) in Lao PDR?
Keep it short and to the point. 0.02. In the year 2001, what is the difference between the General Parity Index (GPI) in Arab World and General Parity Index (GPI) in Paraguay?
Your answer should be compact. -0.08. In the year 2001, what is the difference between the General Parity Index (GPI) in Arab World and General Parity Index (GPI) in Serbia?
Provide a short and direct response. -0.12. In the year 2001, what is the difference between the General Parity Index (GPI) in Lao PDR and General Parity Index (GPI) in Paraguay?
Offer a very short reply. -0.11. In the year 2001, what is the difference between the General Parity Index (GPI) in Lao PDR and General Parity Index (GPI) in Serbia?
Your answer should be very brief. -0.14. In the year 2001, what is the difference between the General Parity Index (GPI) of Paraguay and General Parity Index (GPI) of Serbia?
Make the answer very short. -0.03. In the year 2002, what is the difference between the General Parity Index (GPI) in Arab World and General Parity Index (GPI) in Lao PDR?
Your answer should be very brief. 0.02. In the year 2002, what is the difference between the General Parity Index (GPI) in Arab World and General Parity Index (GPI) in Paraguay?
Your answer should be compact. -0.08. In the year 2002, what is the difference between the General Parity Index (GPI) of Arab World and General Parity Index (GPI) of Serbia?
Your answer should be compact. -0.11. In the year 2002, what is the difference between the General Parity Index (GPI) in Lao PDR and General Parity Index (GPI) in Paraguay?
Provide a short and direct response. -0.1. In the year 2002, what is the difference between the General Parity Index (GPI) of Lao PDR and General Parity Index (GPI) of Serbia?
Offer a terse response. -0.13. In the year 2002, what is the difference between the General Parity Index (GPI) in Paraguay and General Parity Index (GPI) in Serbia?
Your answer should be compact. -0.03. In the year 2003, what is the difference between the General Parity Index (GPI) in Arab World and General Parity Index (GPI) in Lao PDR?
Keep it short and to the point. 0.03. In the year 2003, what is the difference between the General Parity Index (GPI) in Arab World and General Parity Index (GPI) in Paraguay?
Your answer should be very brief. -0.07. In the year 2003, what is the difference between the General Parity Index (GPI) of Arab World and General Parity Index (GPI) of Serbia?
Offer a terse response. -0.11. In the year 2003, what is the difference between the General Parity Index (GPI) in Lao PDR and General Parity Index (GPI) in Paraguay?
Your response must be concise. -0.1. In the year 2003, what is the difference between the General Parity Index (GPI) in Lao PDR and General Parity Index (GPI) in Serbia?
Provide a short and direct response. -0.13. In the year 2003, what is the difference between the General Parity Index (GPI) in Paraguay and General Parity Index (GPI) in Serbia?
Give a very brief answer. -0.03. In the year 2004, what is the difference between the General Parity Index (GPI) of Arab World and General Parity Index (GPI) of Lao PDR?
Your answer should be very brief. 0.02. In the year 2004, what is the difference between the General Parity Index (GPI) in Arab World and General Parity Index (GPI) in Paraguay?
Keep it short and to the point. -0.07. In the year 2004, what is the difference between the General Parity Index (GPI) of Arab World and General Parity Index (GPI) of Serbia?
Keep it short and to the point. -0.1. In the year 2004, what is the difference between the General Parity Index (GPI) in Lao PDR and General Parity Index (GPI) in Paraguay?
Provide a succinct answer. -0.09. In the year 2004, what is the difference between the General Parity Index (GPI) in Lao PDR and General Parity Index (GPI) in Serbia?
Offer a very short reply. -0.12. In the year 2004, what is the difference between the General Parity Index (GPI) of Paraguay and General Parity Index (GPI) of Serbia?
Offer a terse response. -0.03. In the year 2005, what is the difference between the General Parity Index (GPI) in Arab World and General Parity Index (GPI) in Lao PDR?
Offer a very short reply. 0.02. In the year 2005, what is the difference between the General Parity Index (GPI) of Arab World and General Parity Index (GPI) of Paraguay?
Provide a short and direct response. -0.07. In the year 2005, what is the difference between the General Parity Index (GPI) of Arab World and General Parity Index (GPI) of Serbia?
Your answer should be compact. -0.1. In the year 2005, what is the difference between the General Parity Index (GPI) of Lao PDR and General Parity Index (GPI) of Paraguay?
Your answer should be compact. -0.09. In the year 2005, what is the difference between the General Parity Index (GPI) of Lao PDR and General Parity Index (GPI) of Serbia?
Ensure brevity in your answer.  -0.13. In the year 2005, what is the difference between the General Parity Index (GPI) in Paraguay and General Parity Index (GPI) in Serbia?
Ensure brevity in your answer.  -0.03. In the year 2006, what is the difference between the General Parity Index (GPI) of Arab World and General Parity Index (GPI) of Lao PDR?
Your response must be concise. 0.02. In the year 2006, what is the difference between the General Parity Index (GPI) of Arab World and General Parity Index (GPI) of Paraguay?
Offer a terse response. -0.07. In the year 2006, what is the difference between the General Parity Index (GPI) of Arab World and General Parity Index (GPI) of Serbia?
Your answer should be compact. -0.09. In the year 2006, what is the difference between the General Parity Index (GPI) in Lao PDR and General Parity Index (GPI) in Paraguay?
Offer a very short reply. -0.09. In the year 2006, what is the difference between the General Parity Index (GPI) in Lao PDR and General Parity Index (GPI) in Serbia?
Provide a short and direct response. -0.12. In the year 2006, what is the difference between the General Parity Index (GPI) in Paraguay and General Parity Index (GPI) in Serbia?
Provide a succinct answer. -0.03. In the year 2007, what is the difference between the General Parity Index (GPI) of Arab World and General Parity Index (GPI) of Lao PDR?
Your answer should be very brief. 0.01. In the year 2007, what is the difference between the General Parity Index (GPI) in Arab World and General Parity Index (GPI) in Paraguay?
Provide a succinct answer. -0.06. In the year 2007, what is the difference between the General Parity Index (GPI) in Arab World and General Parity Index (GPI) in Serbia?
Ensure brevity in your answer.  -0.09. In the year 2007, what is the difference between the General Parity Index (GPI) in Lao PDR and General Parity Index (GPI) in Paraguay?
Provide a short and direct response. -0.08. In the year 2007, what is the difference between the General Parity Index (GPI) in Lao PDR and General Parity Index (GPI) in Serbia?
Ensure brevity in your answer.  -0.11. In the year 2007, what is the difference between the General Parity Index (GPI) of Paraguay and General Parity Index (GPI) of Serbia?
Give a very brief answer. -0.03. In the year 2008, what is the difference between the General Parity Index (GPI) of Arab World and General Parity Index (GPI) of Lao PDR?
Offer a very short reply. 0.01. In the year 2008, what is the difference between the General Parity Index (GPI) in Arab World and General Parity Index (GPI) in Paraguay?
Offer a very short reply. -0.05. In the year 2008, what is the difference between the General Parity Index (GPI) of Arab World and General Parity Index (GPI) of Serbia?
Ensure brevity in your answer.  -0.09. In the year 2008, what is the difference between the General Parity Index (GPI) of Lao PDR and General Parity Index (GPI) of Paraguay?
Keep it short and to the point. -0.06. In the year 2008, what is the difference between the General Parity Index (GPI) of Lao PDR and General Parity Index (GPI) of Serbia?
Your answer should be very brief. -0.1. In the year 2008, what is the difference between the General Parity Index (GPI) of Paraguay and General Parity Index (GPI) of Serbia?
Your answer should be very brief. -0.03. What is the ratio of the General Parity Index (GPI) of Arab World in 2001 to that in 2002?
Give a very brief answer. 0.99. What is the ratio of the General Parity Index (GPI) in Serbia in 2001 to that in 2002?
Make the answer very short. 1. What is the ratio of the General Parity Index (GPI) of Arab World in 2001 to that in 2003?
Keep it short and to the point. 0.99. What is the ratio of the General Parity Index (GPI) of Lao PDR in 2001 to that in 2003?
Your response must be concise. 0.99. What is the ratio of the General Parity Index (GPI) in Serbia in 2001 to that in 2003?
Ensure brevity in your answer.  1. What is the ratio of the General Parity Index (GPI) of Arab World in 2001 to that in 2004?
Your answer should be compact. 0.98. What is the ratio of the General Parity Index (GPI) in Lao PDR in 2001 to that in 2004?
Give a very brief answer. 0.98. What is the ratio of the General Parity Index (GPI) in Paraguay in 2001 to that in 2004?
Your answer should be very brief. 0.99. What is the ratio of the General Parity Index (GPI) in Arab World in 2001 to that in 2005?
Make the answer very short. 0.98. What is the ratio of the General Parity Index (GPI) in Lao PDR in 2001 to that in 2005?
Keep it short and to the point. 0.98. What is the ratio of the General Parity Index (GPI) in Serbia in 2001 to that in 2005?
Make the answer very short. 0.99. What is the ratio of the General Parity Index (GPI) in Arab World in 2001 to that in 2006?
Offer a terse response. 0.97. What is the ratio of the General Parity Index (GPI) of Lao PDR in 2001 to that in 2006?
Give a very brief answer. 0.97. What is the ratio of the General Parity Index (GPI) of Arab World in 2001 to that in 2007?
Give a very brief answer. 0.97. What is the ratio of the General Parity Index (GPI) in Lao PDR in 2001 to that in 2007?
Provide a succinct answer. 0.96. What is the ratio of the General Parity Index (GPI) of Paraguay in 2001 to that in 2007?
Provide a succinct answer. 1. What is the ratio of the General Parity Index (GPI) of Lao PDR in 2001 to that in 2008?
Ensure brevity in your answer.  0.95. What is the ratio of the General Parity Index (GPI) in Serbia in 2001 to that in 2008?
Give a very brief answer. 1. What is the ratio of the General Parity Index (GPI) in Lao PDR in 2002 to that in 2003?
Your answer should be compact. 0.99. What is the ratio of the General Parity Index (GPI) in Arab World in 2002 to that in 2004?
Give a very brief answer. 0.99. What is the ratio of the General Parity Index (GPI) in Lao PDR in 2002 to that in 2004?
Your response must be concise. 0.98. What is the ratio of the General Parity Index (GPI) in Paraguay in 2002 to that in 2004?
Provide a succinct answer. 0.99. What is the ratio of the General Parity Index (GPI) in Arab World in 2002 to that in 2005?
Provide a short and direct response. 0.98. What is the ratio of the General Parity Index (GPI) in Lao PDR in 2002 to that in 2005?
Ensure brevity in your answer.  0.98. What is the ratio of the General Parity Index (GPI) of Serbia in 2002 to that in 2005?
Give a very brief answer. 0.99. What is the ratio of the General Parity Index (GPI) in Arab World in 2002 to that in 2006?
Keep it short and to the point. 0.98. What is the ratio of the General Parity Index (GPI) of Lao PDR in 2002 to that in 2006?
Make the answer very short. 0.98. What is the ratio of the General Parity Index (GPI) of Paraguay in 2002 to that in 2006?
Offer a terse response. 0.99. What is the ratio of the General Parity Index (GPI) in Arab World in 2002 to that in 2007?
Keep it short and to the point. 0.98. What is the ratio of the General Parity Index (GPI) in Lao PDR in 2002 to that in 2007?
Give a very brief answer. 0.97. What is the ratio of the General Parity Index (GPI) of Serbia in 2002 to that in 2007?
Your answer should be compact. 1. What is the ratio of the General Parity Index (GPI) of Arab World in 2002 to that in 2008?
Ensure brevity in your answer.  0.97. What is the ratio of the General Parity Index (GPI) in Lao PDR in 2002 to that in 2008?
Ensure brevity in your answer.  0.96. What is the ratio of the General Parity Index (GPI) in Serbia in 2002 to that in 2008?
Your answer should be compact. 1. What is the ratio of the General Parity Index (GPI) of Lao PDR in 2003 to that in 2004?
Offer a terse response. 0.99. What is the ratio of the General Parity Index (GPI) of Paraguay in 2003 to that in 2004?
Make the answer very short. 1. What is the ratio of the General Parity Index (GPI) of Serbia in 2003 to that in 2004?
Provide a short and direct response. 1. What is the ratio of the General Parity Index (GPI) of Arab World in 2003 to that in 2005?
Your answer should be compact. 0.99. What is the ratio of the General Parity Index (GPI) of Lao PDR in 2003 to that in 2005?
Your answer should be very brief. 0.99. What is the ratio of the General Parity Index (GPI) of Paraguay in 2003 to that in 2005?
Provide a short and direct response. 1. What is the ratio of the General Parity Index (GPI) of Serbia in 2003 to that in 2005?
Ensure brevity in your answer.  1. What is the ratio of the General Parity Index (GPI) in Lao PDR in 2003 to that in 2006?
Offer a very short reply. 0.98. What is the ratio of the General Parity Index (GPI) of Paraguay in 2003 to that in 2006?
Provide a short and direct response. 1. What is the ratio of the General Parity Index (GPI) of Arab World in 2003 to that in 2007?
Offer a terse response. 0.99. What is the ratio of the General Parity Index (GPI) of Lao PDR in 2003 to that in 2007?
Provide a short and direct response. 0.97. What is the ratio of the General Parity Index (GPI) of Arab World in 2003 to that in 2008?
Offer a very short reply. 0.98. What is the ratio of the General Parity Index (GPI) in Lao PDR in 2003 to that in 2008?
Offer a terse response. 0.96. What is the ratio of the General Parity Index (GPI) of Paraguay in 2003 to that in 2008?
Ensure brevity in your answer.  1. What is the ratio of the General Parity Index (GPI) of Arab World in 2004 to that in 2005?
Offer a terse response. 1. What is the ratio of the General Parity Index (GPI) of Paraguay in 2004 to that in 2005?
Ensure brevity in your answer.  1. What is the ratio of the General Parity Index (GPI) in Arab World in 2004 to that in 2006?
Ensure brevity in your answer.  0.99. What is the ratio of the General Parity Index (GPI) of Paraguay in 2004 to that in 2006?
Offer a very short reply. 1. What is the ratio of the General Parity Index (GPI) in Serbia in 2004 to that in 2006?
Make the answer very short. 1. What is the ratio of the General Parity Index (GPI) of Lao PDR in 2004 to that in 2007?
Your answer should be very brief. 0.98. What is the ratio of the General Parity Index (GPI) in Paraguay in 2004 to that in 2007?
Offer a terse response. 1. What is the ratio of the General Parity Index (GPI) of Serbia in 2004 to that in 2007?
Make the answer very short. 1. What is the ratio of the General Parity Index (GPI) of Arab World in 2004 to that in 2008?
Keep it short and to the point. 0.98. What is the ratio of the General Parity Index (GPI) of Lao PDR in 2004 to that in 2008?
Offer a terse response. 0.97. What is the ratio of the General Parity Index (GPI) in Paraguay in 2004 to that in 2008?
Your response must be concise. 1. What is the ratio of the General Parity Index (GPI) of Serbia in 2004 to that in 2008?
Your response must be concise. 1. What is the ratio of the General Parity Index (GPI) in Serbia in 2005 to that in 2006?
Offer a very short reply. 1.01. What is the ratio of the General Parity Index (GPI) of Lao PDR in 2005 to that in 2007?
Keep it short and to the point. 0.98. What is the ratio of the General Parity Index (GPI) in Serbia in 2005 to that in 2007?
Provide a succinct answer. 1.01. What is the ratio of the General Parity Index (GPI) of Arab World in 2005 to that in 2008?
Offer a very short reply. 0.99. What is the ratio of the General Parity Index (GPI) in Lao PDR in 2005 to that in 2008?
Provide a succinct answer. 0.97. What is the ratio of the General Parity Index (GPI) in Paraguay in 2005 to that in 2008?
Keep it short and to the point. 1.01. What is the ratio of the General Parity Index (GPI) of Serbia in 2005 to that in 2008?
Your answer should be compact. 1.01. What is the ratio of the General Parity Index (GPI) in Lao PDR in 2006 to that in 2007?
Offer a very short reply. 0.99. What is the ratio of the General Parity Index (GPI) of Paraguay in 2006 to that in 2007?
Keep it short and to the point. 1. What is the ratio of the General Parity Index (GPI) of Serbia in 2006 to that in 2007?
Offer a very short reply. 1. What is the ratio of the General Parity Index (GPI) of Arab World in 2006 to that in 2008?
Offer a very short reply. 0.99. What is the ratio of the General Parity Index (GPI) of Lao PDR in 2006 to that in 2008?
Your answer should be very brief. 0.98. What is the ratio of the General Parity Index (GPI) in Paraguay in 2006 to that in 2008?
Your answer should be compact. 1. What is the ratio of the General Parity Index (GPI) of Arab World in 2007 to that in 2008?
Provide a short and direct response. 0.99. What is the ratio of the General Parity Index (GPI) of Lao PDR in 2007 to that in 2008?
Your answer should be very brief. 0.99. What is the difference between the highest and the second highest General Parity Index (GPI) in Arab World?
Your response must be concise. 0.01. What is the difference between the highest and the second highest General Parity Index (GPI) of Lao PDR?
Offer a very short reply. 0.01. What is the difference between the highest and the second highest General Parity Index (GPI) in Paraguay?
Provide a short and direct response. 0. What is the difference between the highest and the second highest General Parity Index (GPI) in Serbia?
Ensure brevity in your answer.  0. What is the difference between the highest and the lowest General Parity Index (GPI) of Arab World?
Give a very brief answer. 0.03. What is the difference between the highest and the lowest General Parity Index (GPI) in Lao PDR?
Provide a short and direct response. 0.04. What is the difference between the highest and the lowest General Parity Index (GPI) of Paraguay?
Make the answer very short. 0.01. What is the difference between the highest and the lowest General Parity Index (GPI) of Serbia?
Give a very brief answer. 0.01. 